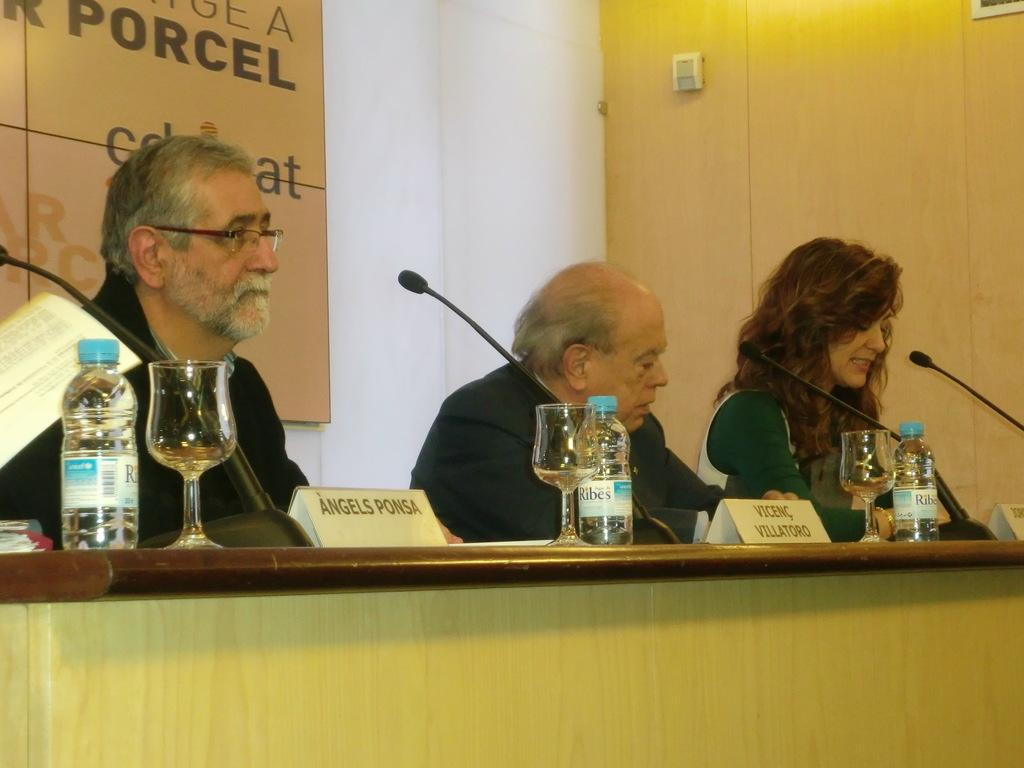Provide a one-sentence caption for the provided image. Angels Ponsa sits before a microphone wearing glasses and looking outward into the room. 